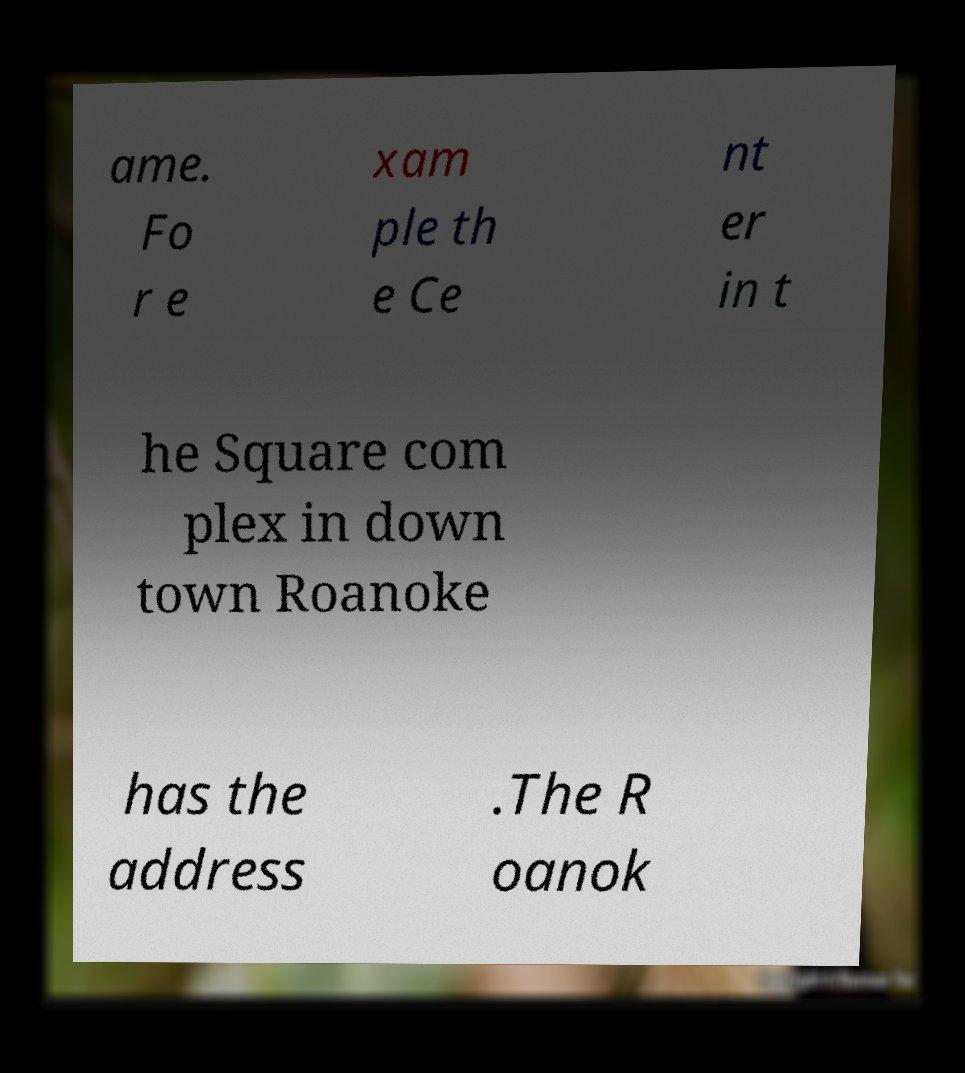Can you read and provide the text displayed in the image?This photo seems to have some interesting text. Can you extract and type it out for me? ame. Fo r e xam ple th e Ce nt er in t he Square com plex in down town Roanoke has the address .The R oanok 